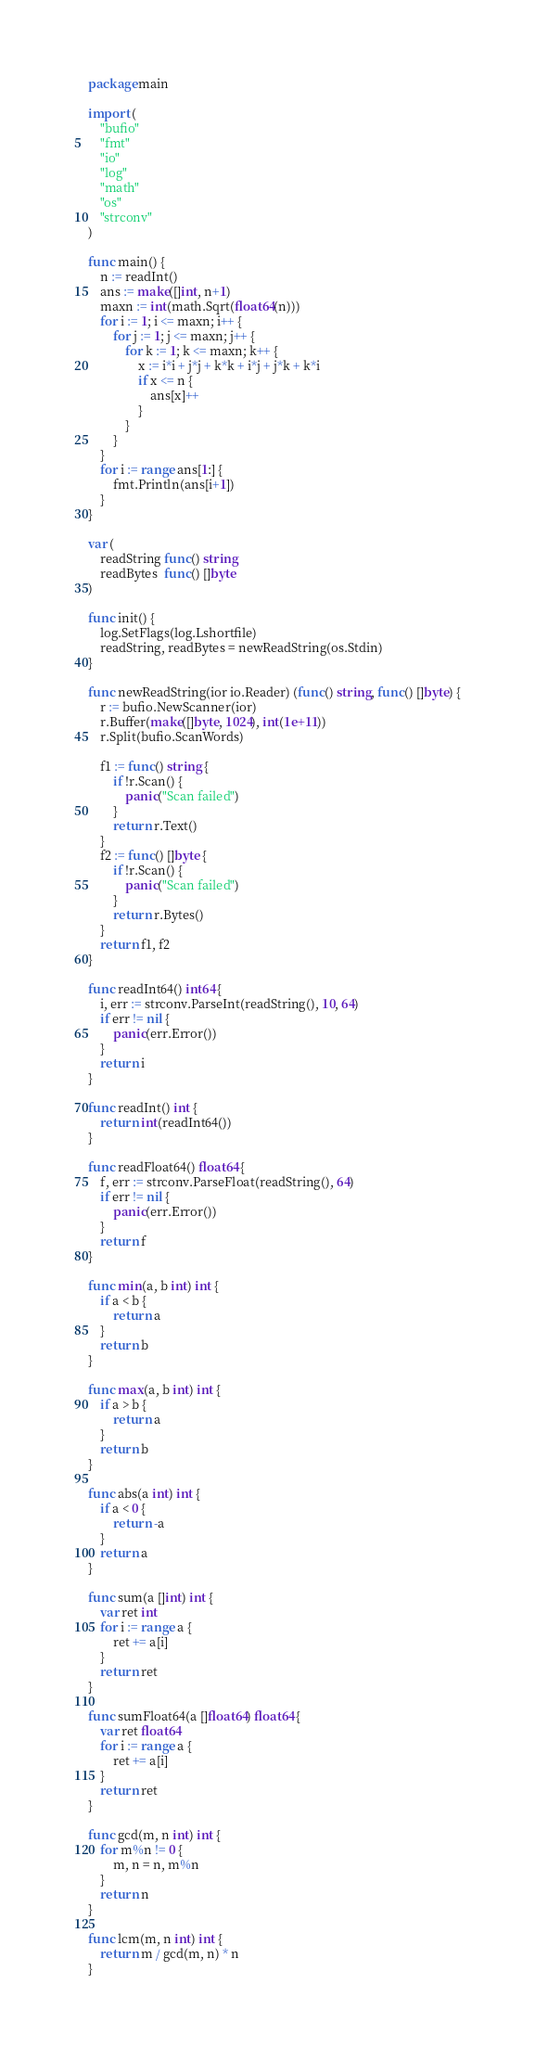<code> <loc_0><loc_0><loc_500><loc_500><_Go_>package main

import (
	"bufio"
	"fmt"
	"io"
	"log"
	"math"
	"os"
	"strconv"
)

func main() {
	n := readInt()
	ans := make([]int, n+1)
	maxn := int(math.Sqrt(float64(n)))
	for i := 1; i <= maxn; i++ {
		for j := 1; j <= maxn; j++ {
			for k := 1; k <= maxn; k++ {
				x := i*i + j*j + k*k + i*j + j*k + k*i
				if x <= n {
					ans[x]++
				}
			}
		}
	}
	for i := range ans[1:] {
		fmt.Println(ans[i+1])
	}
}

var (
	readString func() string
	readBytes  func() []byte
)

func init() {
	log.SetFlags(log.Lshortfile)
	readString, readBytes = newReadString(os.Stdin)
}

func newReadString(ior io.Reader) (func() string, func() []byte) {
	r := bufio.NewScanner(ior)
	r.Buffer(make([]byte, 1024), int(1e+11))
	r.Split(bufio.ScanWords)

	f1 := func() string {
		if !r.Scan() {
			panic("Scan failed")
		}
		return r.Text()
	}
	f2 := func() []byte {
		if !r.Scan() {
			panic("Scan failed")
		}
		return r.Bytes()
	}
	return f1, f2
}

func readInt64() int64 {
	i, err := strconv.ParseInt(readString(), 10, 64)
	if err != nil {
		panic(err.Error())
	}
	return i
}

func readInt() int {
	return int(readInt64())
}

func readFloat64() float64 {
	f, err := strconv.ParseFloat(readString(), 64)
	if err != nil {
		panic(err.Error())
	}
	return f
}

func min(a, b int) int {
	if a < b {
		return a
	}
	return b
}

func max(a, b int) int {
	if a > b {
		return a
	}
	return b
}

func abs(a int) int {
	if a < 0 {
		return -a
	}
	return a
}

func sum(a []int) int {
	var ret int
	for i := range a {
		ret += a[i]
	}
	return ret
}

func sumFloat64(a []float64) float64 {
	var ret float64
	for i := range a {
		ret += a[i]
	}
	return ret
}

func gcd(m, n int) int {
	for m%n != 0 {
		m, n = n, m%n
	}
	return n
}

func lcm(m, n int) int {
	return m / gcd(m, n) * n
}
</code> 